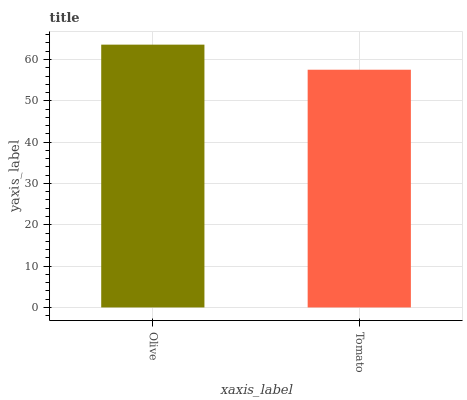Is Tomato the minimum?
Answer yes or no. Yes. Is Olive the maximum?
Answer yes or no. Yes. Is Tomato the maximum?
Answer yes or no. No. Is Olive greater than Tomato?
Answer yes or no. Yes. Is Tomato less than Olive?
Answer yes or no. Yes. Is Tomato greater than Olive?
Answer yes or no. No. Is Olive less than Tomato?
Answer yes or no. No. Is Olive the high median?
Answer yes or no. Yes. Is Tomato the low median?
Answer yes or no. Yes. Is Tomato the high median?
Answer yes or no. No. Is Olive the low median?
Answer yes or no. No. 